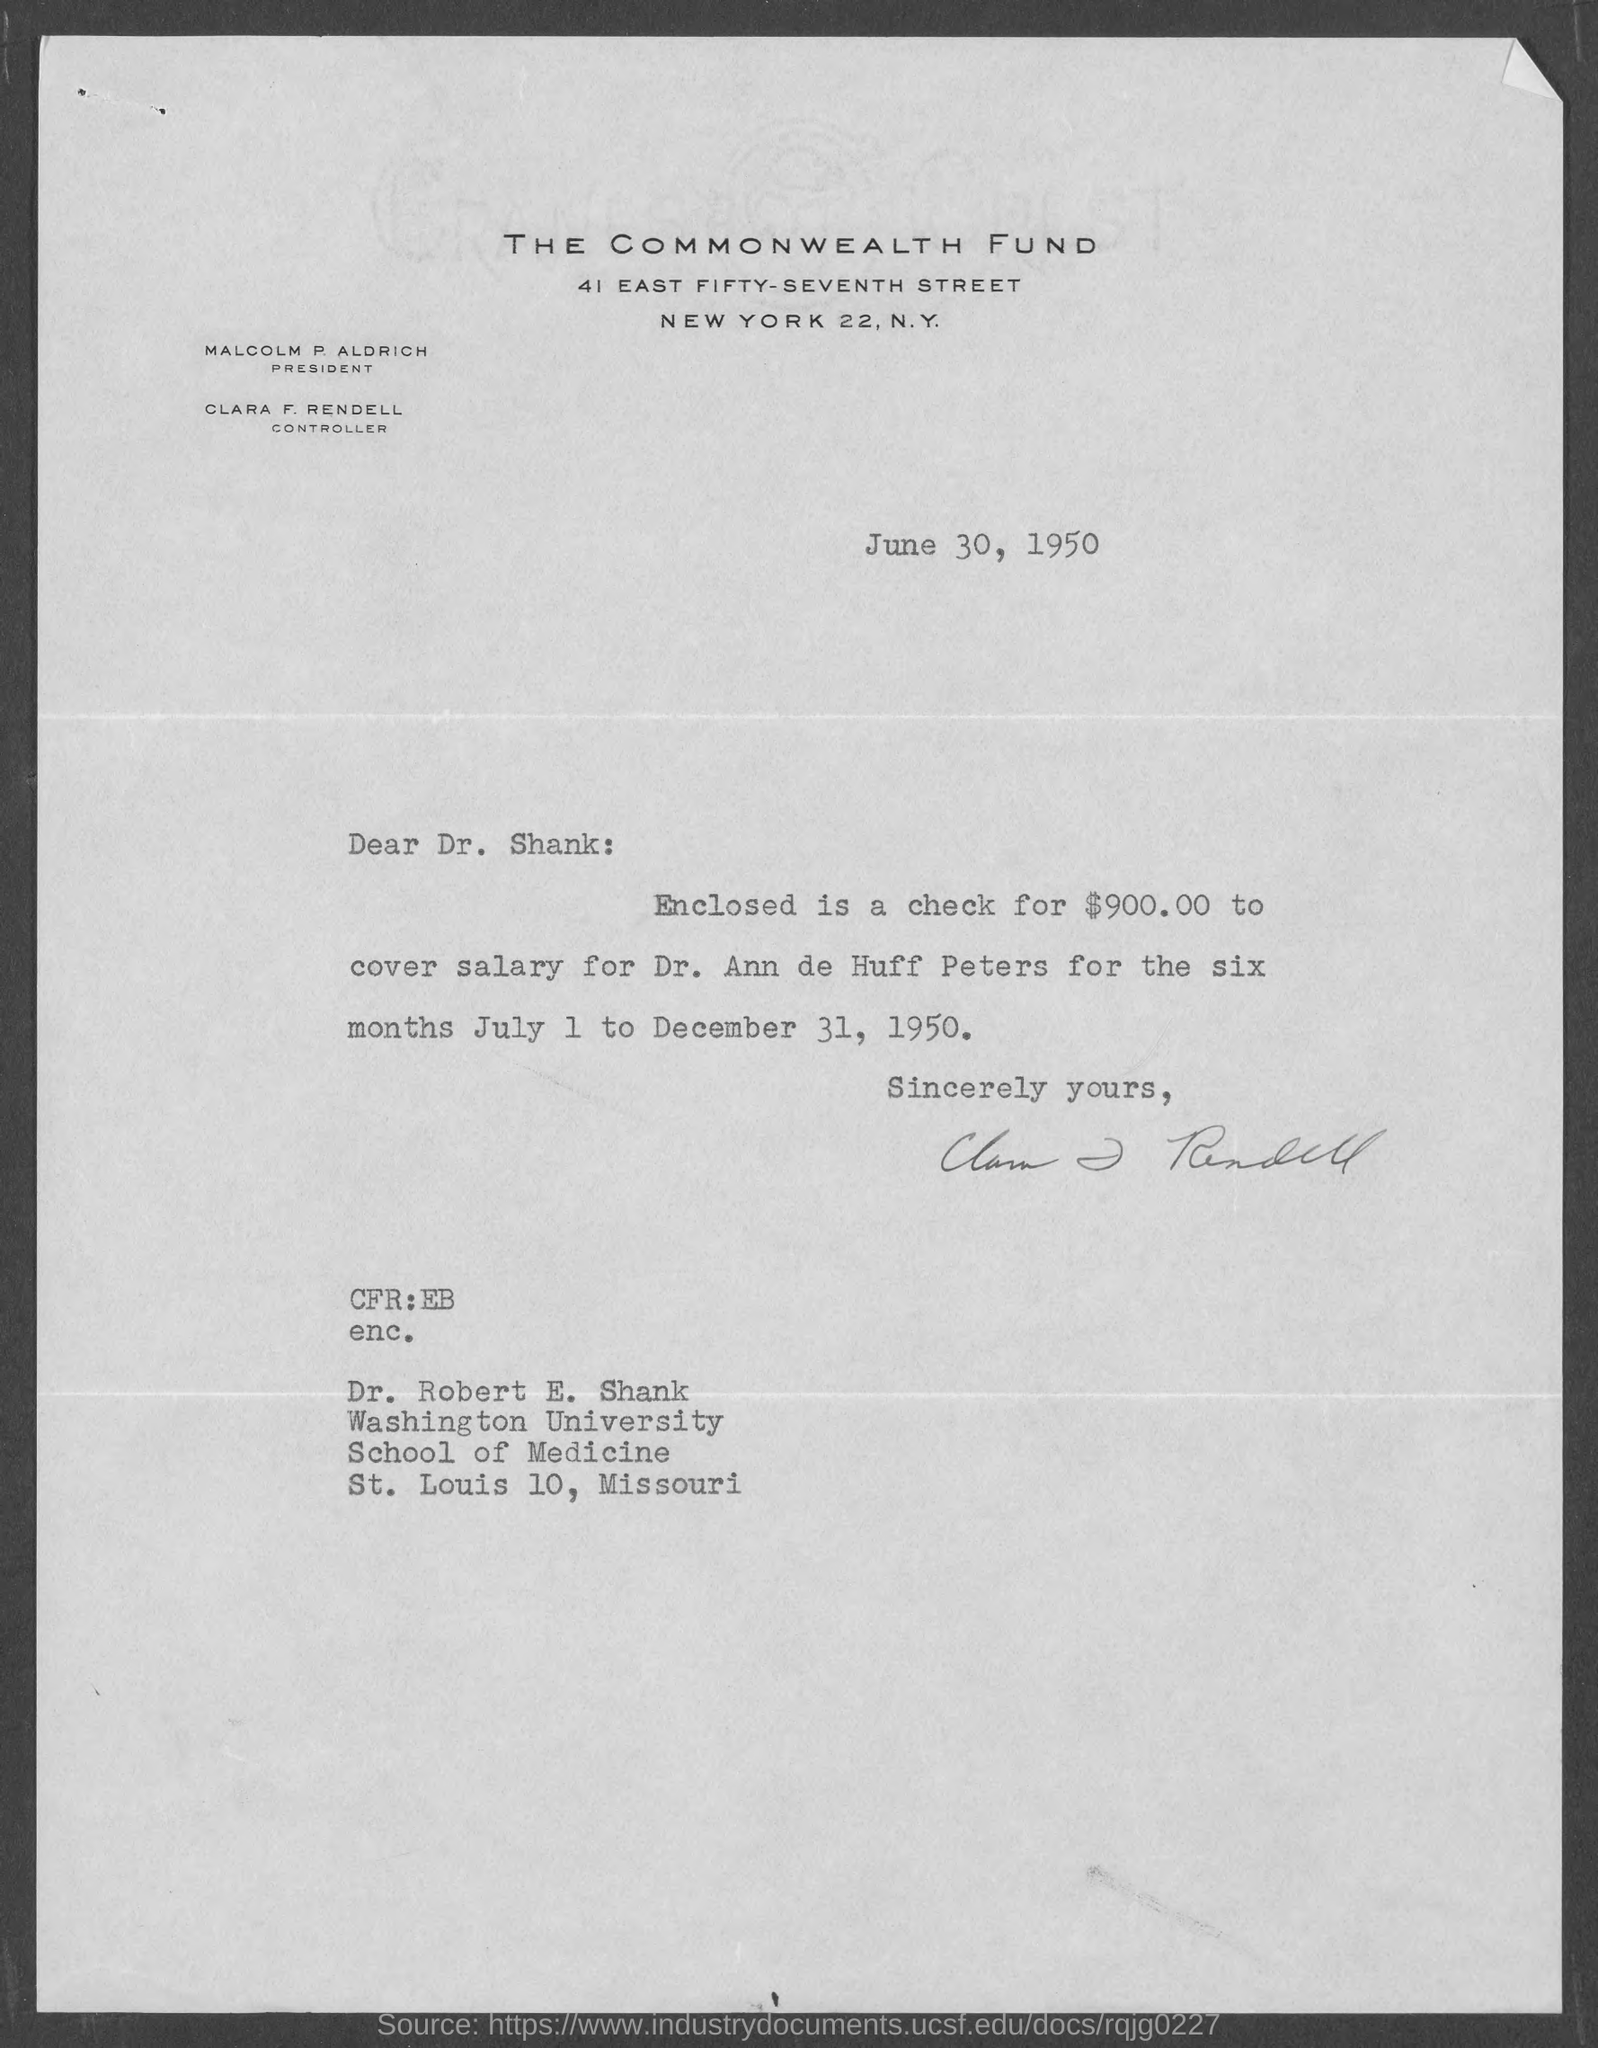Specify some key components in this picture. Clara F. Rendell is the controller of The Commonwealth Fund. The enclosed check is intended to cover the salary of Dr. Ann de Huff Peters. The address of Washington University School of Medicine in St. Louis, Missouri, is located at 10 St. Louis. The letter, dated June 30, 1950, indicates that... The amount in the check enclosed with the letter is $900.00. 